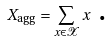<formula> <loc_0><loc_0><loc_500><loc_500>X _ { \text {agg} } = \sum _ { x \in \mathcal { X } } x \text { .}</formula> 